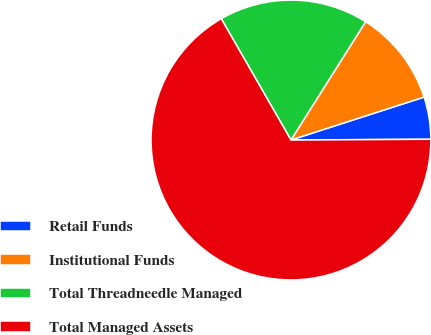Convert chart. <chart><loc_0><loc_0><loc_500><loc_500><pie_chart><fcel>Retail Funds<fcel>Institutional Funds<fcel>Total Threadneedle Managed<fcel>Total Managed Assets<nl><fcel>4.88%<fcel>11.07%<fcel>17.26%<fcel>66.78%<nl></chart> 